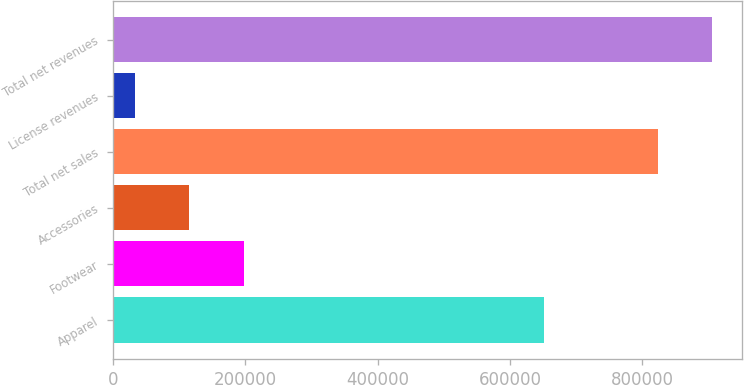Convert chart. <chart><loc_0><loc_0><loc_500><loc_500><bar_chart><fcel>Apparel<fcel>Footwear<fcel>Accessories<fcel>Total net sales<fcel>License revenues<fcel>Total net revenues<nl><fcel>651779<fcel>197947<fcel>115639<fcel>823080<fcel>33331<fcel>905388<nl></chart> 